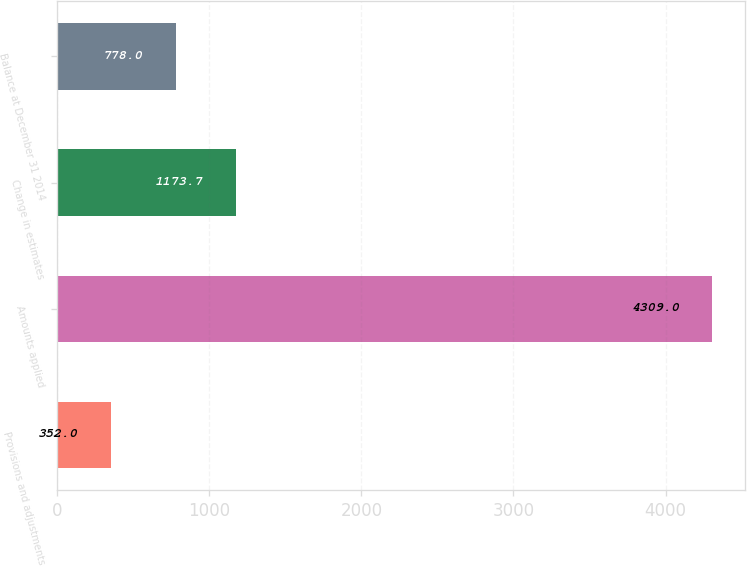Convert chart. <chart><loc_0><loc_0><loc_500><loc_500><bar_chart><fcel>Provisions and adjustments<fcel>Amounts applied<fcel>Change in estimates<fcel>Balance at December 31 2014<nl><fcel>352<fcel>4309<fcel>1173.7<fcel>778<nl></chart> 